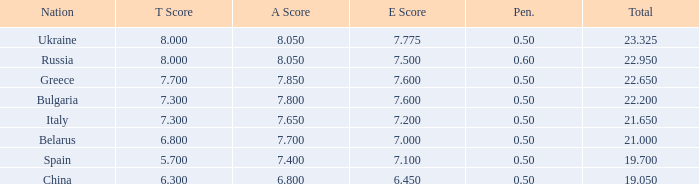What's the aggregate of a score possessing a score less than None. 